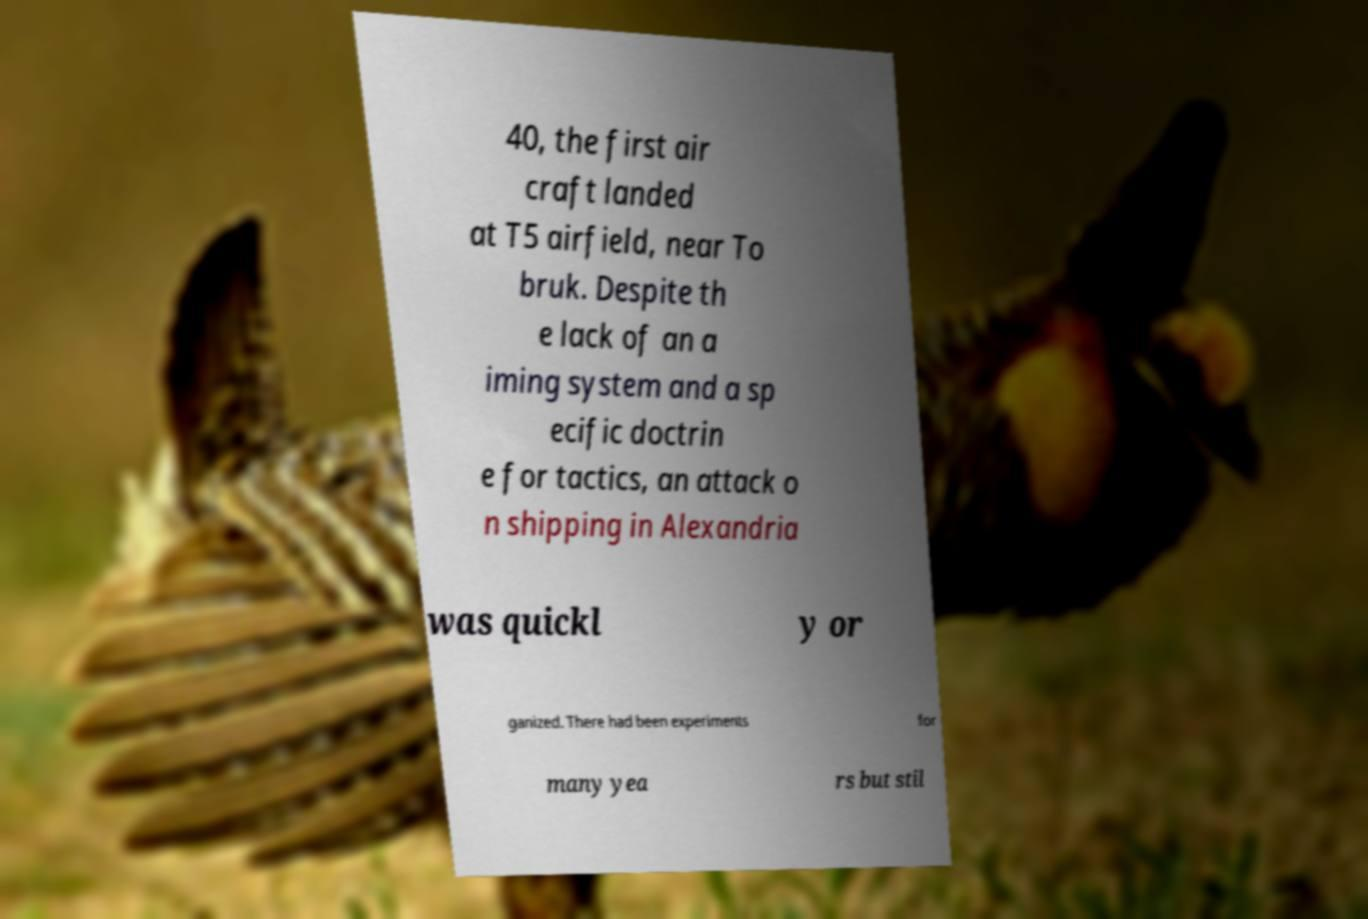Please identify and transcribe the text found in this image. 40, the first air craft landed at T5 airfield, near To bruk. Despite th e lack of an a iming system and a sp ecific doctrin e for tactics, an attack o n shipping in Alexandria was quickl y or ganized. There had been experiments for many yea rs but stil 